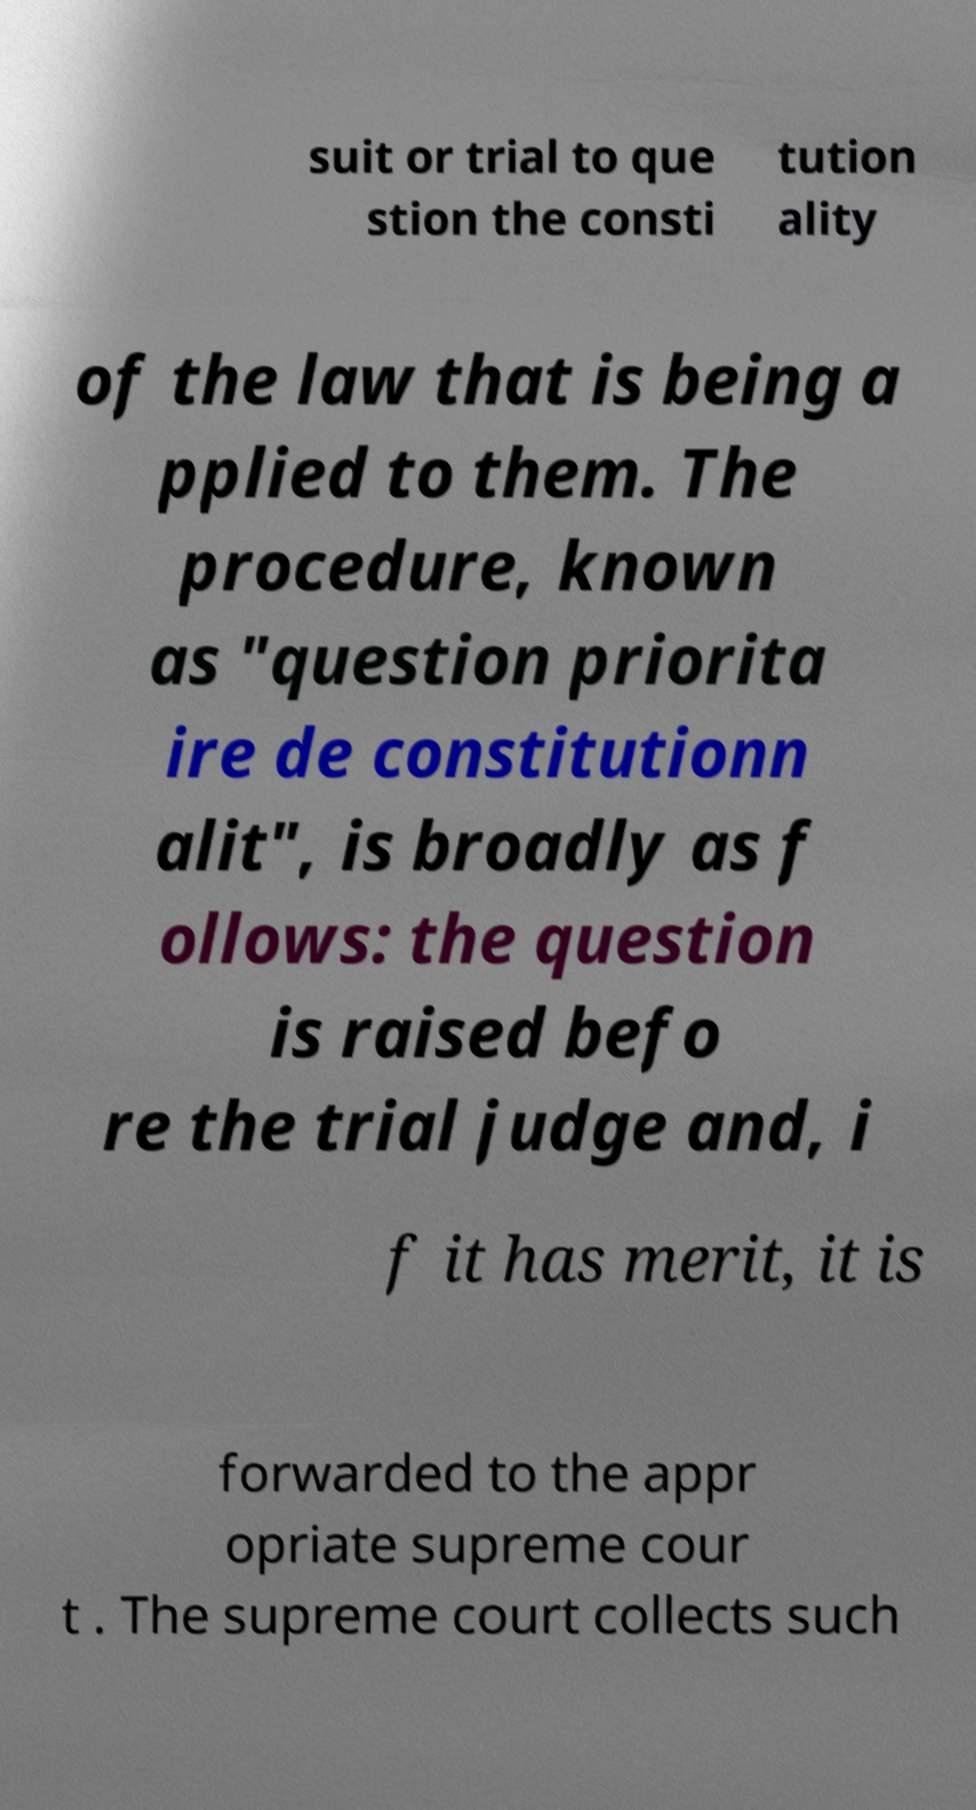Please identify and transcribe the text found in this image. suit or trial to que stion the consti tution ality of the law that is being a pplied to them. The procedure, known as "question priorita ire de constitutionn alit", is broadly as f ollows: the question is raised befo re the trial judge and, i f it has merit, it is forwarded to the appr opriate supreme cour t . The supreme court collects such 